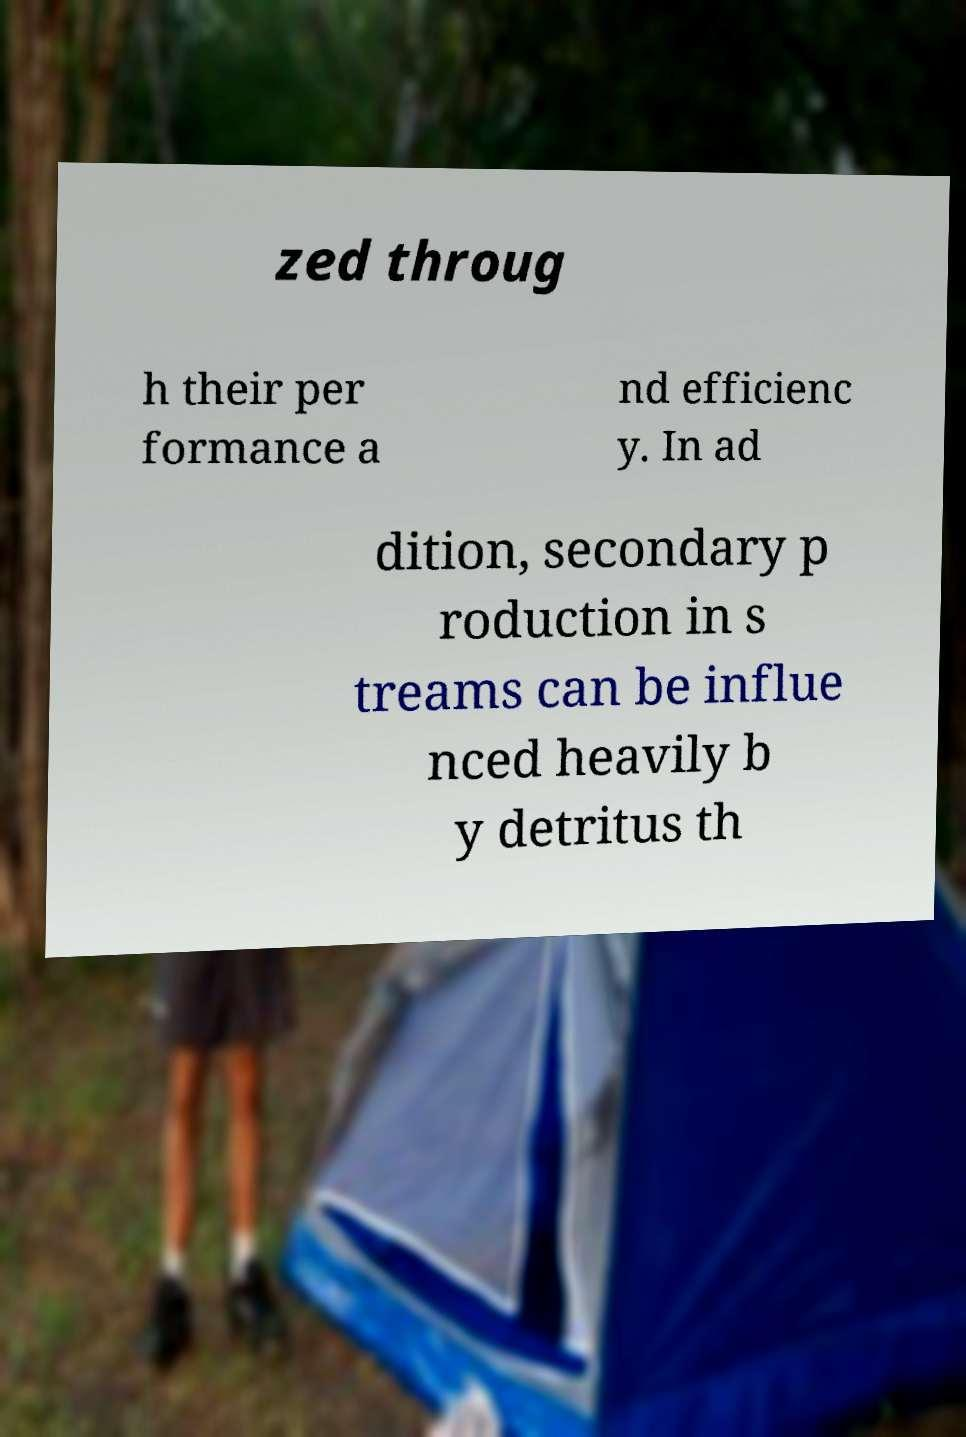I need the written content from this picture converted into text. Can you do that? zed throug h their per formance a nd efficienc y. In ad dition, secondary p roduction in s treams can be influe nced heavily b y detritus th 